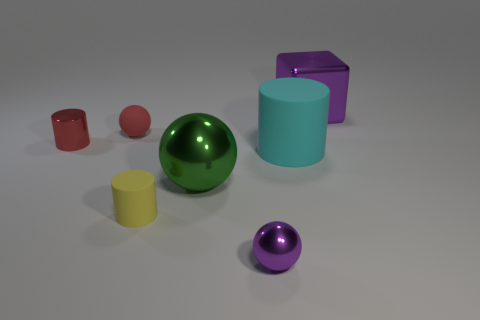Are there any objects that share the same color but differ in shape? Yes, there are two purple objects that vary in shape; one is a smaller sphere and the other is a cube. 